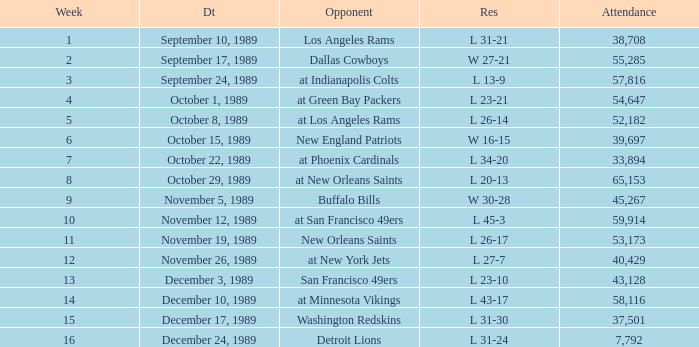For what week was the attendance 40,429? 12.0. 